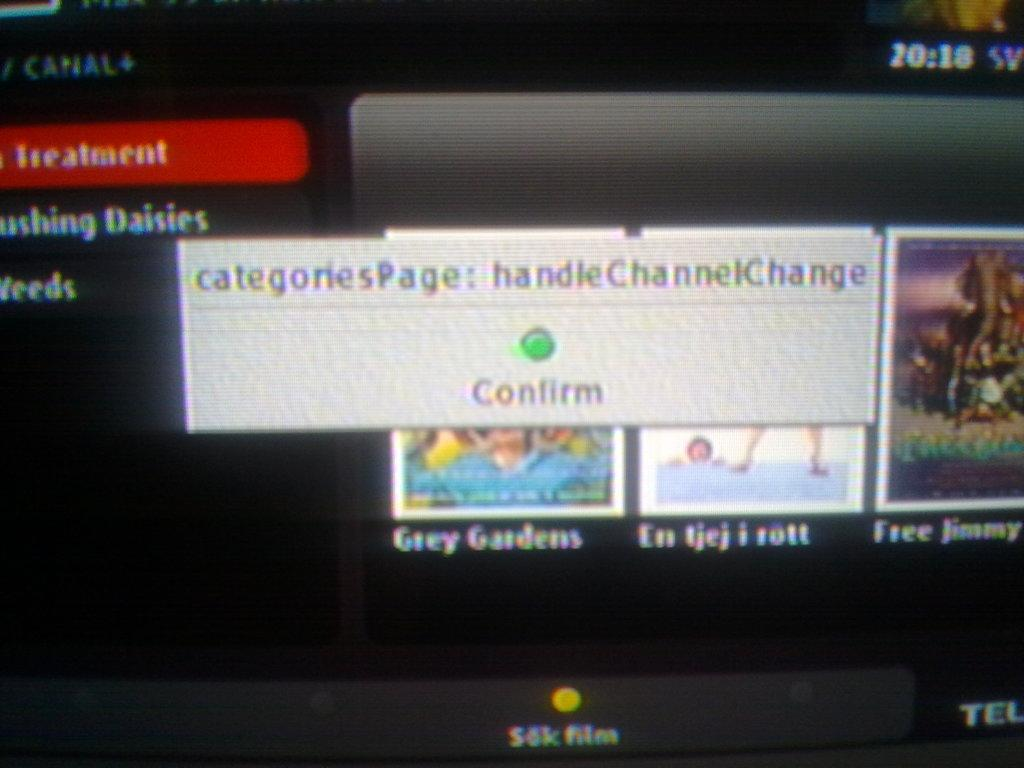<image>
Create a compact narrative representing the image presented. The pop up on the screen is asking you to confirm the change. 